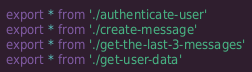Convert code to text. <code><loc_0><loc_0><loc_500><loc_500><_TypeScript_>export * from './authenticate-user'
export * from './create-message'
export * from './get-the-last-3-messages'
export * from './get-user-data'
</code> 